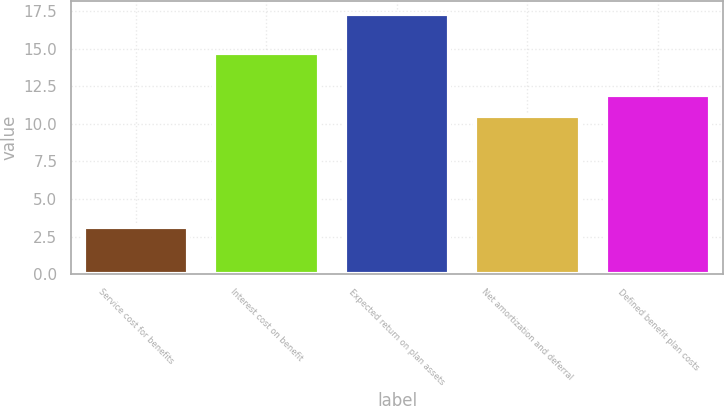Convert chart to OTSL. <chart><loc_0><loc_0><loc_500><loc_500><bar_chart><fcel>Service cost for benefits<fcel>Interest cost on benefit<fcel>Expected return on plan assets<fcel>Net amortization and deferral<fcel>Defined benefit plan costs<nl><fcel>3.1<fcel>14.7<fcel>17.3<fcel>10.5<fcel>11.92<nl></chart> 